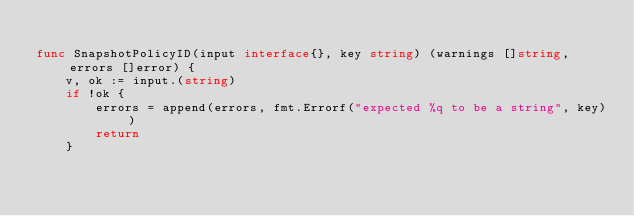<code> <loc_0><loc_0><loc_500><loc_500><_Go_>
func SnapshotPolicyID(input interface{}, key string) (warnings []string, errors []error) {
	v, ok := input.(string)
	if !ok {
		errors = append(errors, fmt.Errorf("expected %q to be a string", key))
		return
	}
</code> 